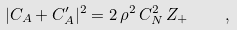Convert formula to latex. <formula><loc_0><loc_0><loc_500><loc_500>| C _ { A } + C _ { A } ^ { \prime } | ^ { 2 } = 2 \, \rho ^ { 2 } \, C _ { N } ^ { 2 } \, Z _ { + } \quad ,</formula> 